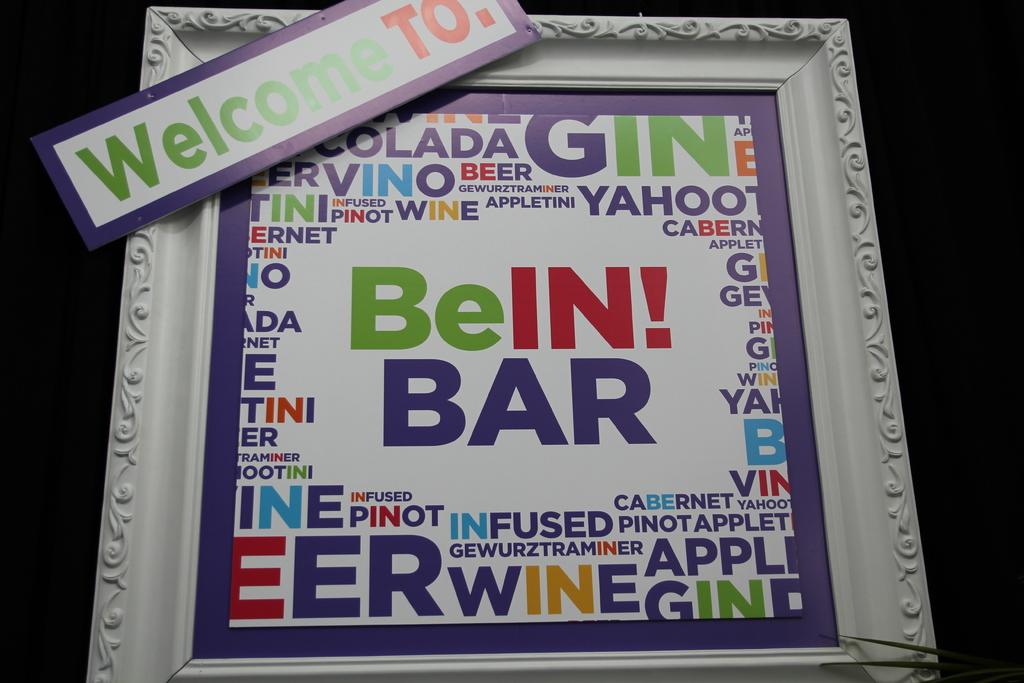Where are they welcoming you to?
Make the answer very short. Bein! bar. Name a drink on on this poster?
Ensure brevity in your answer.  Wine. 